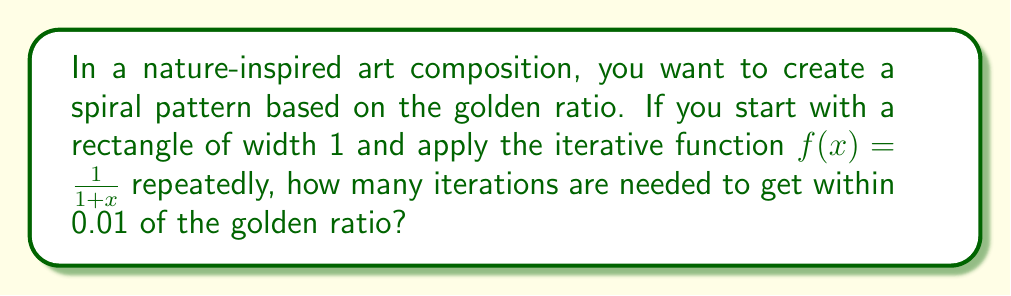Can you solve this math problem? Let's approach this step-by-step:

1) The golden ratio, often denoted by $\phi$, is approximately 1.618034. Its exact value is $\frac{1+\sqrt{5}}{2}$.

2) The iterative function $f(x) = \frac{1}{1+x}$ converges to the golden ratio minus 1, or $\phi - 1$.

3) We start with $x_0 = 1$ (the initial width of the rectangle), and apply the function repeatedly:

   $x_1 = f(1) = \frac{1}{1+1} = 0.5$
   $x_2 = f(0.5) = \frac{1}{1+0.5} = \frac{2}{3} \approx 0.6667$
   $x_3 = f(\frac{2}{3}) = \frac{1}{1+\frac{2}{3}} = \frac{3}{5} = 0.6$
   $x_4 = f(0.6) = \frac{1}{1+0.6} = \frac{5}{8} = 0.625$

4) We continue this process until we get close enough to $\phi - 1 \approx 0.618034$.

5) After 11 iterations:
   $x_{11} \approx 0.6180257$

6) After 12 iterations:
   $x_{12} \approx 0.6180344$

7) The difference between $x_{12}$ and $\phi - 1$ is approximately 0.0000004, which is less than 0.01.

Therefore, 12 iterations are needed to get within 0.01 of the golden ratio minus 1.
Answer: 12 iterations 